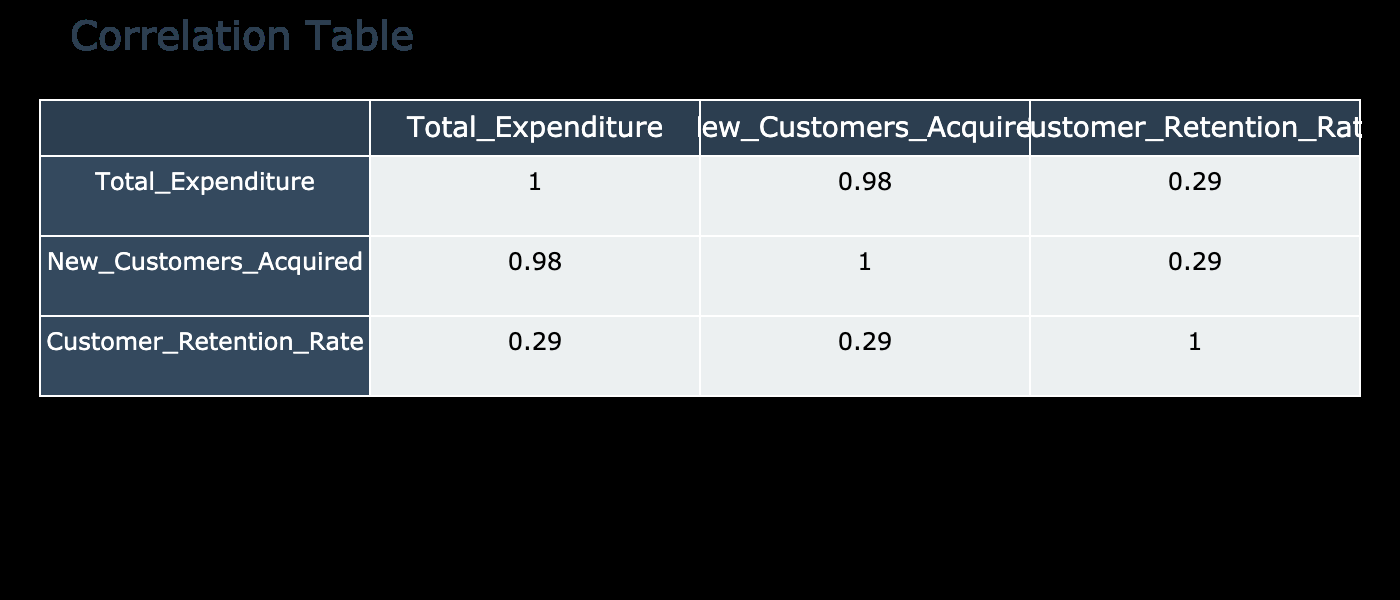What is the Customer Retention Rate for the Holiday Extravaganza campaign? The Customer Retention Rate for the Holiday Extravaganza campaign can be found in the table under Customer Retention Rate for Campaign_ID 4. The value listed is 85.
Answer: 85 What was the Total Expenditure for the Summer Loyalty Program? The Total Expenditure for the Summer Loyalty Program can be found in the table under Total Expenditure for Campaign_ID 2. The value listed is 1000.
Answer: 1000 Which campaign had the highest number of New Customers Acquired? To find which campaign had the highest number of New Customers Acquired, we look at the New Customers Acquired column. The Holiday Extravaganza campaign (Campaign_ID 4) with 300 has the highest value.
Answer: Holiday Extravaganza What is the average Customer Retention Rate for all campaigns? To calculate the average Customer Retention Rate, we add all the Customer Retention Rates (75, 80, 70, 85, 78, 82, and 76), which sums up to 526, and then divide by the number of campaigns (7). This gives us an average of 526/7 = 75.43.
Answer: 75.43 Does the Fall Fest campaign have a higher Customer Retention Rate than the New Year Celebration campaign? The Customer Retention Rate for the Fall Fest campaign is 70, while for the New Year Celebration campaign it is 78. Since 70 is less than 78, the statement is false.
Answer: No What was the Total Expenditure for the campaign with the least Customer Retention Rate? First, we look for the campaign with the least Customer Retention Rate, which is Fall Fest (70). Next, we find the Total Expenditure from the Total Expenditure column for Campaign_ID 3, which is 1200.
Answer: 1200 What is the combined Total Expenditure for campaigns with a Customer Retention Rate above 80? The campaigns with a Customer Retention Rate above 80 are the Summer Loyalty Program (1000), Holiday Extravaganza (2000), and Back to School (950). Adding these gives us a Total Expenditure of 1000 + 2000 + 950 = 3950.
Answer: 3950 Which promotion was offered during the Spring Sale campaign? According to the Promotions Offered column for Campaign_ID 1 (Spring Sale), the promotion offered was a 20% Discount.
Answer: 20% Discount 